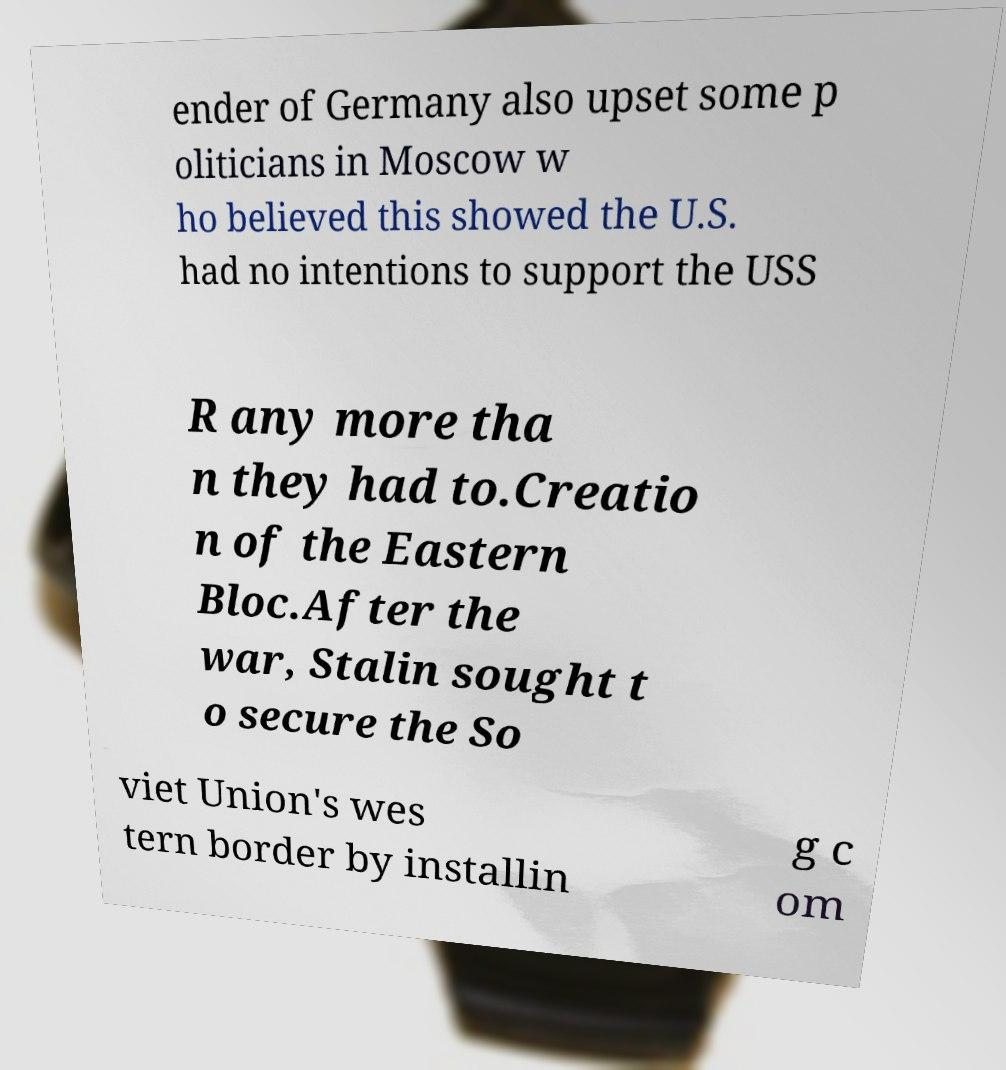Could you extract and type out the text from this image? ender of Germany also upset some p oliticians in Moscow w ho believed this showed the U.S. had no intentions to support the USS R any more tha n they had to.Creatio n of the Eastern Bloc.After the war, Stalin sought t o secure the So viet Union's wes tern border by installin g c om 